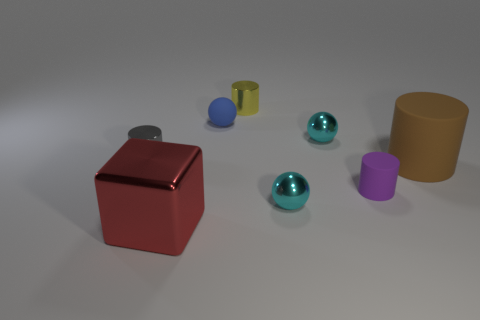What number of objects are cylinders behind the blue object or small metal things that are in front of the tiny blue sphere?
Offer a terse response. 4. Is the number of tiny yellow cylinders that are in front of the gray metal cylinder less than the number of matte balls?
Make the answer very short. Yes. Are the small blue ball and the large object that is behind the purple thing made of the same material?
Keep it short and to the point. Yes. What is the yellow object made of?
Make the answer very short. Metal. What material is the large red block that is on the left side of the tiny sphere that is left of the metallic cylinder to the right of the tiny gray shiny object?
Your answer should be very brief. Metal. Do the large matte object and the tiny cylinder behind the gray metal cylinder have the same color?
Offer a terse response. No. Is there any other thing that has the same shape as the purple thing?
Offer a terse response. Yes. The tiny cylinder on the left side of the small cylinder that is behind the blue matte sphere is what color?
Ensure brevity in your answer.  Gray. What number of small gray metallic cylinders are there?
Make the answer very short. 1. What number of metal things are either blocks or cylinders?
Keep it short and to the point. 3. 